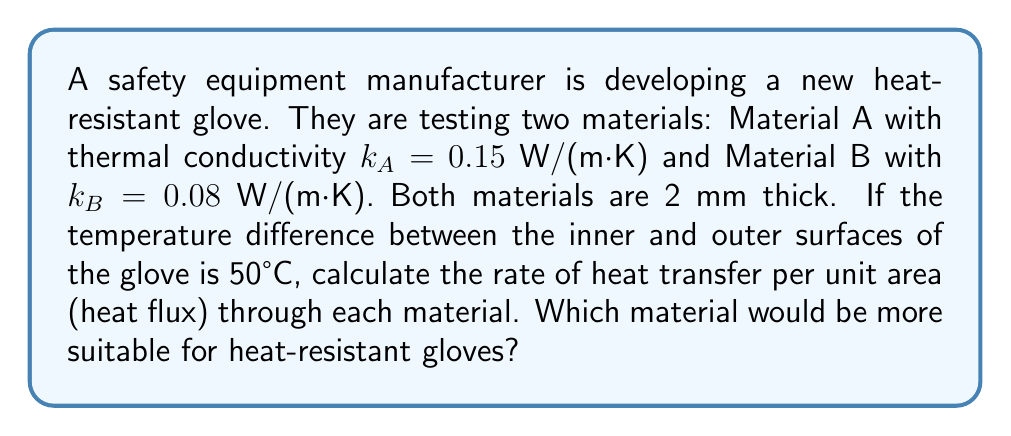Give your solution to this math problem. To solve this problem, we'll use Fourier's Law of Heat Conduction:

$$q = -k \frac{dT}{dx}$$

Where:
$q$ = heat flux (W/m²)
$k$ = thermal conductivity (W/(m·K))
$\frac{dT}{dx}$ = temperature gradient (K/m)

For a uniform material with constant thermal conductivity:

$$q = k \frac{\Delta T}{L}$$

Where:
$\Delta T$ = temperature difference (K)
$L$ = material thickness (m)

Given:
- Material A: $k_A = 0.15$ W/(m·K)
- Material B: $k_B = 0.08$ W/(m·K)
- Thickness: $L = 2$ mm = 0.002 m
- Temperature difference: $\Delta T = 50°C = 50$ K

Step 1: Calculate heat flux for Material A
$$q_A = k_A \frac{\Delta T}{L} = 0.15 \frac{50}{0.002} = 3750 \text{ W/m²}$$

Step 2: Calculate heat flux for Material B
$$q_B = k_B \frac{\Delta T}{L} = 0.08 \frac{50}{0.002} = 2000 \text{ W/m²}$$

Step 3: Compare the results
Material B has a lower heat flux, meaning it transfers less heat per unit area. This makes it more suitable for heat-resistant gloves as it provides better insulation.
Answer: Material A: 3750 W/m²; Material B: 2000 W/m²; Material B is more suitable. 